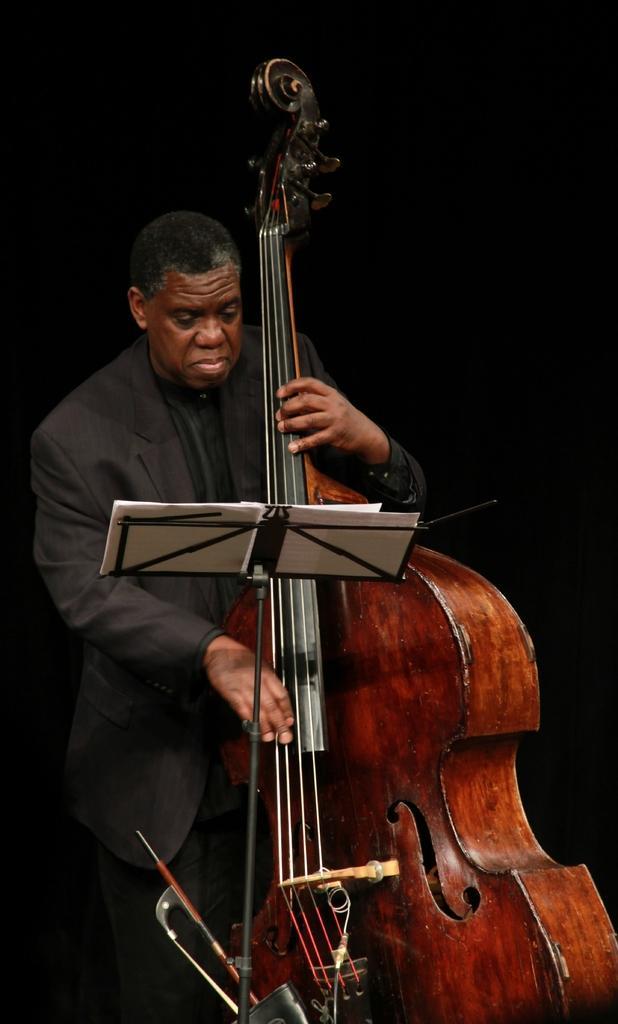In one or two sentences, can you explain what this image depicts? In the image there is a man who is holding his violin in front of a table. On table we can see a book. 